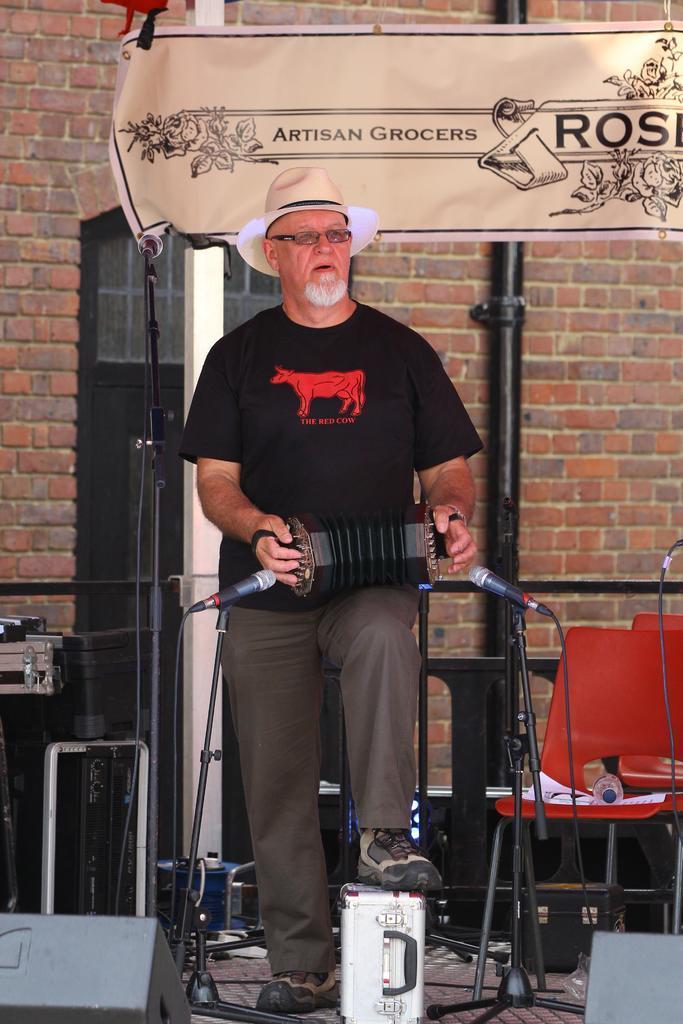In one or two sentences, can you explain what this image depicts? In this image I can see a man is standing and I can see he is holding a musical instrument. I can also see a briefcase under his leg. I can see he is wearing a black colour t shirt, pant, shoes, a specs and a hat. In the front of him I can see two mics and other stuffs. In the background I can see few chairs, a bottle, few papers, a board, the wall and on the board I can see something is written. I can also see few other stuffs in the background. 